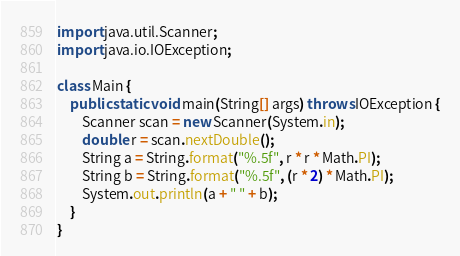Convert code to text. <code><loc_0><loc_0><loc_500><loc_500><_Java_>import java.util.Scanner;
import java.io.IOException;

class Main {
	public static void main(String[] args) throws IOException {
		Scanner scan = new Scanner(System.in);
		double r = scan.nextDouble();
		String a = String.format("%.5f", r * r * Math.PI);
		String b = String.format("%.5f", (r * 2) * Math.PI);
		System.out.println(a + " " + b);
	}
}</code> 